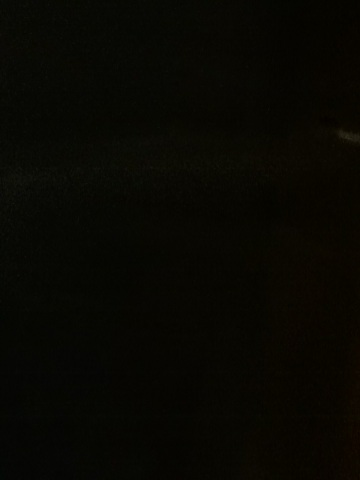Is there anything I can do to make objects in such a dark image more visible? If you have the original photo, you could try increasing the brightness and contrast using photo editing software. Additionally, some cameras have built-in low-light modes or features such as long exposure that can make objects in dark images more visible if you are taking a new photo. 